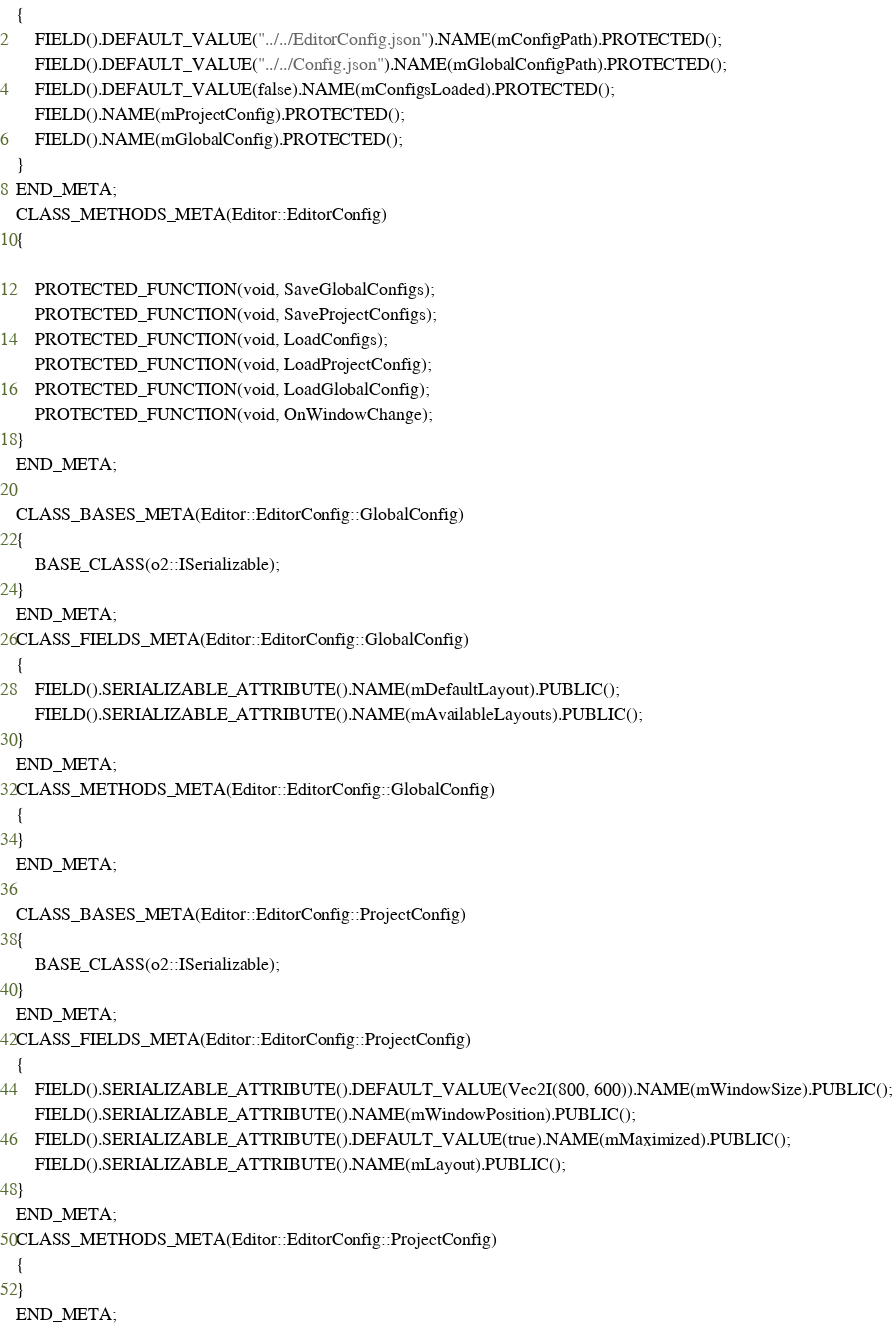Convert code to text. <code><loc_0><loc_0><loc_500><loc_500><_C_>{
	FIELD().DEFAULT_VALUE("../../EditorConfig.json").NAME(mConfigPath).PROTECTED();
	FIELD().DEFAULT_VALUE("../../Config.json").NAME(mGlobalConfigPath).PROTECTED();
	FIELD().DEFAULT_VALUE(false).NAME(mConfigsLoaded).PROTECTED();
	FIELD().NAME(mProjectConfig).PROTECTED();
	FIELD().NAME(mGlobalConfig).PROTECTED();
}
END_META;
CLASS_METHODS_META(Editor::EditorConfig)
{

	PROTECTED_FUNCTION(void, SaveGlobalConfigs);
	PROTECTED_FUNCTION(void, SaveProjectConfigs);
	PROTECTED_FUNCTION(void, LoadConfigs);
	PROTECTED_FUNCTION(void, LoadProjectConfig);
	PROTECTED_FUNCTION(void, LoadGlobalConfig);
	PROTECTED_FUNCTION(void, OnWindowChange);
}
END_META;

CLASS_BASES_META(Editor::EditorConfig::GlobalConfig)
{
	BASE_CLASS(o2::ISerializable);
}
END_META;
CLASS_FIELDS_META(Editor::EditorConfig::GlobalConfig)
{
	FIELD().SERIALIZABLE_ATTRIBUTE().NAME(mDefaultLayout).PUBLIC();
	FIELD().SERIALIZABLE_ATTRIBUTE().NAME(mAvailableLayouts).PUBLIC();
}
END_META;
CLASS_METHODS_META(Editor::EditorConfig::GlobalConfig)
{
}
END_META;

CLASS_BASES_META(Editor::EditorConfig::ProjectConfig)
{
	BASE_CLASS(o2::ISerializable);
}
END_META;
CLASS_FIELDS_META(Editor::EditorConfig::ProjectConfig)
{
	FIELD().SERIALIZABLE_ATTRIBUTE().DEFAULT_VALUE(Vec2I(800, 600)).NAME(mWindowSize).PUBLIC();
	FIELD().SERIALIZABLE_ATTRIBUTE().NAME(mWindowPosition).PUBLIC();
	FIELD().SERIALIZABLE_ATTRIBUTE().DEFAULT_VALUE(true).NAME(mMaximized).PUBLIC();
	FIELD().SERIALIZABLE_ATTRIBUTE().NAME(mLayout).PUBLIC();
}
END_META;
CLASS_METHODS_META(Editor::EditorConfig::ProjectConfig)
{
}
END_META;
</code> 